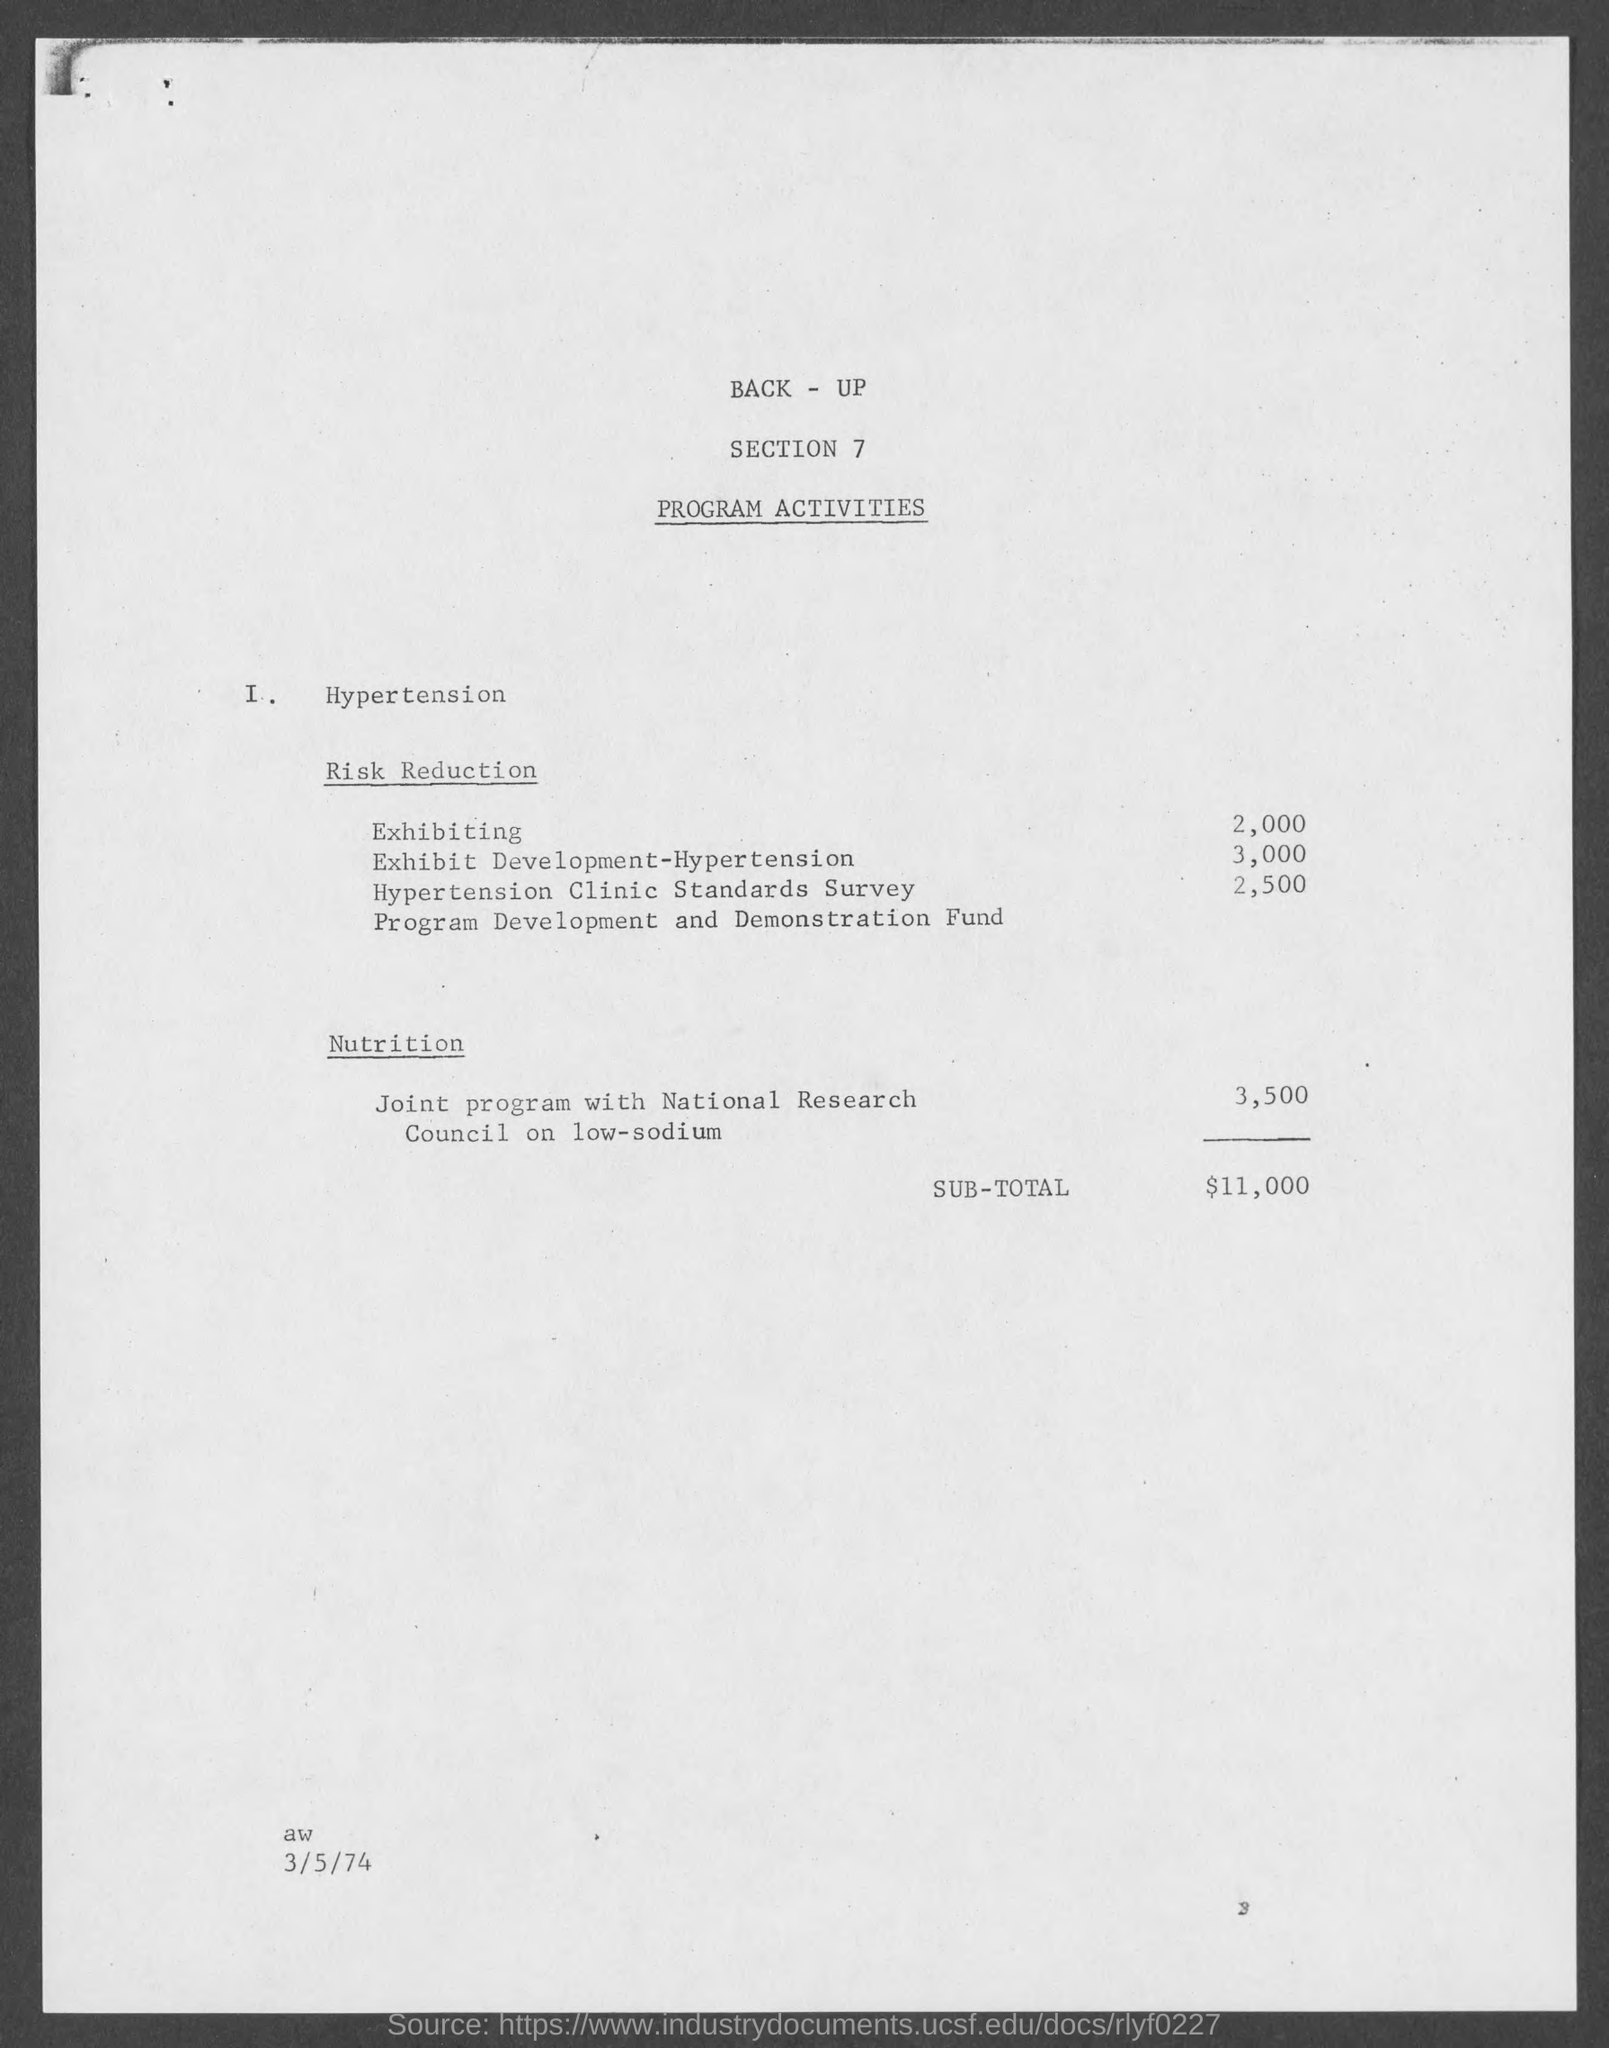What is the cOST OF Exhibiting?
Make the answer very short. 2,000. What is the cost of Exhibit Development-Hypertension?
Your answer should be very brief. 3,000. What is the Sub-Total?
Ensure brevity in your answer.  $11,000. 